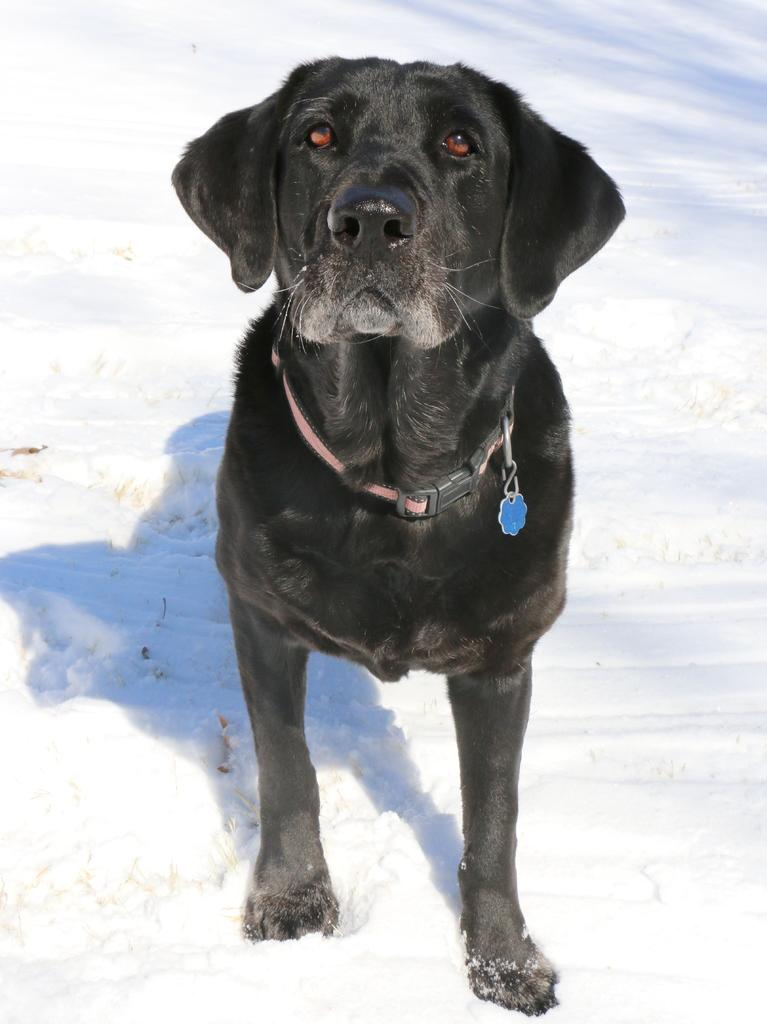What type of animal is in the image? There is a dog in the image. What is the dog wearing? The dog is wearing a belt. Where is the dog located? The dog is on the snow. What type of stove can be seen in the image? There is no stove present in the image; it features a dog on the snow wearing a belt. 